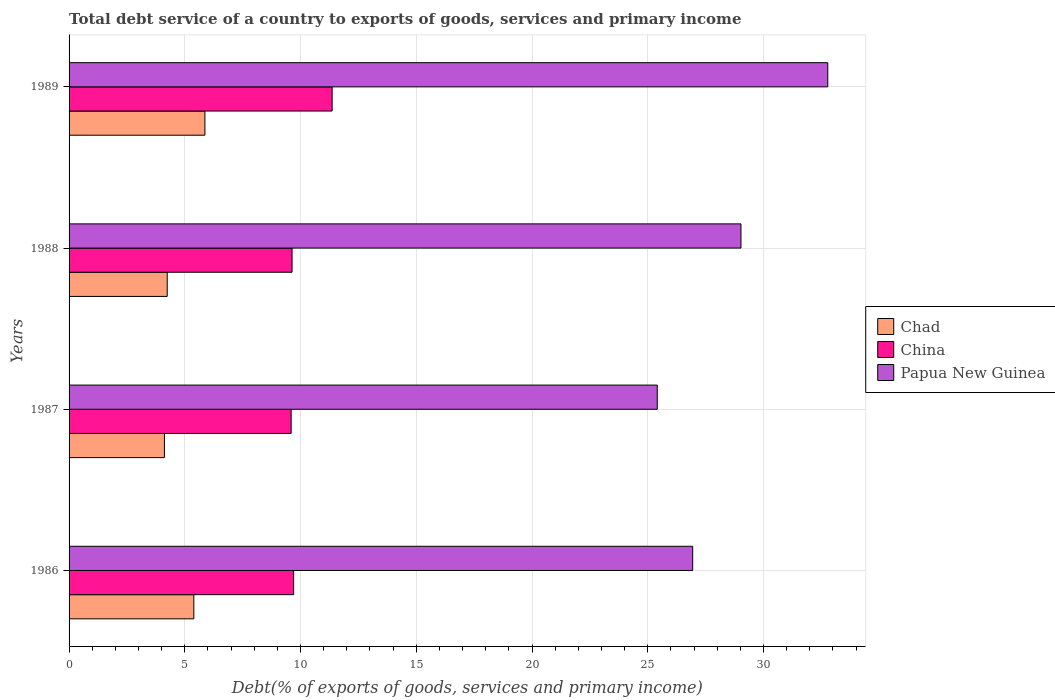Are the number of bars per tick equal to the number of legend labels?
Make the answer very short. Yes. How many bars are there on the 2nd tick from the bottom?
Provide a succinct answer. 3. In how many cases, is the number of bars for a given year not equal to the number of legend labels?
Offer a terse response. 0. What is the total debt service in Chad in 1986?
Offer a very short reply. 5.39. Across all years, what is the maximum total debt service in China?
Your answer should be very brief. 11.36. Across all years, what is the minimum total debt service in Chad?
Provide a succinct answer. 4.12. In which year was the total debt service in China maximum?
Provide a succinct answer. 1989. What is the total total debt service in Chad in the graph?
Offer a terse response. 19.62. What is the difference between the total debt service in Chad in 1987 and that in 1988?
Give a very brief answer. -0.12. What is the difference between the total debt service in China in 1987 and the total debt service in Chad in 1986?
Your answer should be very brief. 4.2. What is the average total debt service in Papua New Guinea per year?
Offer a very short reply. 28.54. In the year 1989, what is the difference between the total debt service in China and total debt service in Papua New Guinea?
Ensure brevity in your answer.  -21.41. What is the ratio of the total debt service in Chad in 1986 to that in 1989?
Offer a terse response. 0.92. Is the total debt service in China in 1987 less than that in 1988?
Give a very brief answer. Yes. What is the difference between the highest and the second highest total debt service in Chad?
Your answer should be compact. 0.48. What is the difference between the highest and the lowest total debt service in Chad?
Provide a short and direct response. 1.75. In how many years, is the total debt service in Papua New Guinea greater than the average total debt service in Papua New Guinea taken over all years?
Your response must be concise. 2. Is the sum of the total debt service in Chad in 1986 and 1987 greater than the maximum total debt service in Papua New Guinea across all years?
Provide a short and direct response. No. What does the 1st bar from the top in 1988 represents?
Keep it short and to the point. Papua New Guinea. How many bars are there?
Offer a very short reply. 12. Are the values on the major ticks of X-axis written in scientific E-notation?
Give a very brief answer. No. Where does the legend appear in the graph?
Provide a succinct answer. Center right. How are the legend labels stacked?
Offer a terse response. Vertical. What is the title of the graph?
Offer a terse response. Total debt service of a country to exports of goods, services and primary income. Does "San Marino" appear as one of the legend labels in the graph?
Provide a short and direct response. No. What is the label or title of the X-axis?
Ensure brevity in your answer.  Debt(% of exports of goods, services and primary income). What is the label or title of the Y-axis?
Your answer should be compact. Years. What is the Debt(% of exports of goods, services and primary income) of Chad in 1986?
Keep it short and to the point. 5.39. What is the Debt(% of exports of goods, services and primary income) in China in 1986?
Your answer should be very brief. 9.7. What is the Debt(% of exports of goods, services and primary income) of Papua New Guinea in 1986?
Provide a succinct answer. 26.94. What is the Debt(% of exports of goods, services and primary income) in Chad in 1987?
Your response must be concise. 4.12. What is the Debt(% of exports of goods, services and primary income) of China in 1987?
Ensure brevity in your answer.  9.59. What is the Debt(% of exports of goods, services and primary income) in Papua New Guinea in 1987?
Provide a short and direct response. 25.41. What is the Debt(% of exports of goods, services and primary income) of Chad in 1988?
Give a very brief answer. 4.24. What is the Debt(% of exports of goods, services and primary income) of China in 1988?
Keep it short and to the point. 9.63. What is the Debt(% of exports of goods, services and primary income) of Papua New Guinea in 1988?
Offer a terse response. 29.03. What is the Debt(% of exports of goods, services and primary income) in Chad in 1989?
Your answer should be compact. 5.87. What is the Debt(% of exports of goods, services and primary income) of China in 1989?
Ensure brevity in your answer.  11.36. What is the Debt(% of exports of goods, services and primary income) in Papua New Guinea in 1989?
Provide a succinct answer. 32.78. Across all years, what is the maximum Debt(% of exports of goods, services and primary income) in Chad?
Ensure brevity in your answer.  5.87. Across all years, what is the maximum Debt(% of exports of goods, services and primary income) in China?
Give a very brief answer. 11.36. Across all years, what is the maximum Debt(% of exports of goods, services and primary income) of Papua New Guinea?
Provide a short and direct response. 32.78. Across all years, what is the minimum Debt(% of exports of goods, services and primary income) of Chad?
Provide a succinct answer. 4.12. Across all years, what is the minimum Debt(% of exports of goods, services and primary income) of China?
Your response must be concise. 9.59. Across all years, what is the minimum Debt(% of exports of goods, services and primary income) in Papua New Guinea?
Your answer should be very brief. 25.41. What is the total Debt(% of exports of goods, services and primary income) of Chad in the graph?
Give a very brief answer. 19.62. What is the total Debt(% of exports of goods, services and primary income) in China in the graph?
Your answer should be very brief. 40.29. What is the total Debt(% of exports of goods, services and primary income) of Papua New Guinea in the graph?
Provide a short and direct response. 114.16. What is the difference between the Debt(% of exports of goods, services and primary income) of Chad in 1986 and that in 1987?
Give a very brief answer. 1.27. What is the difference between the Debt(% of exports of goods, services and primary income) of China in 1986 and that in 1987?
Keep it short and to the point. 0.11. What is the difference between the Debt(% of exports of goods, services and primary income) in Papua New Guinea in 1986 and that in 1987?
Give a very brief answer. 1.53. What is the difference between the Debt(% of exports of goods, services and primary income) of Chad in 1986 and that in 1988?
Make the answer very short. 1.15. What is the difference between the Debt(% of exports of goods, services and primary income) in China in 1986 and that in 1988?
Provide a succinct answer. 0.07. What is the difference between the Debt(% of exports of goods, services and primary income) of Papua New Guinea in 1986 and that in 1988?
Keep it short and to the point. -2.09. What is the difference between the Debt(% of exports of goods, services and primary income) in Chad in 1986 and that in 1989?
Give a very brief answer. -0.48. What is the difference between the Debt(% of exports of goods, services and primary income) in China in 1986 and that in 1989?
Your answer should be very brief. -1.66. What is the difference between the Debt(% of exports of goods, services and primary income) of Papua New Guinea in 1986 and that in 1989?
Provide a succinct answer. -5.84. What is the difference between the Debt(% of exports of goods, services and primary income) of Chad in 1987 and that in 1988?
Give a very brief answer. -0.12. What is the difference between the Debt(% of exports of goods, services and primary income) in China in 1987 and that in 1988?
Keep it short and to the point. -0.04. What is the difference between the Debt(% of exports of goods, services and primary income) of Papua New Guinea in 1987 and that in 1988?
Your answer should be very brief. -3.62. What is the difference between the Debt(% of exports of goods, services and primary income) in Chad in 1987 and that in 1989?
Your answer should be compact. -1.75. What is the difference between the Debt(% of exports of goods, services and primary income) in China in 1987 and that in 1989?
Give a very brief answer. -1.77. What is the difference between the Debt(% of exports of goods, services and primary income) of Papua New Guinea in 1987 and that in 1989?
Make the answer very short. -7.37. What is the difference between the Debt(% of exports of goods, services and primary income) in Chad in 1988 and that in 1989?
Offer a very short reply. -1.63. What is the difference between the Debt(% of exports of goods, services and primary income) in China in 1988 and that in 1989?
Make the answer very short. -1.73. What is the difference between the Debt(% of exports of goods, services and primary income) of Papua New Guinea in 1988 and that in 1989?
Provide a short and direct response. -3.75. What is the difference between the Debt(% of exports of goods, services and primary income) of Chad in 1986 and the Debt(% of exports of goods, services and primary income) of China in 1987?
Your answer should be very brief. -4.2. What is the difference between the Debt(% of exports of goods, services and primary income) of Chad in 1986 and the Debt(% of exports of goods, services and primary income) of Papua New Guinea in 1987?
Ensure brevity in your answer.  -20.02. What is the difference between the Debt(% of exports of goods, services and primary income) in China in 1986 and the Debt(% of exports of goods, services and primary income) in Papua New Guinea in 1987?
Give a very brief answer. -15.71. What is the difference between the Debt(% of exports of goods, services and primary income) in Chad in 1986 and the Debt(% of exports of goods, services and primary income) in China in 1988?
Keep it short and to the point. -4.24. What is the difference between the Debt(% of exports of goods, services and primary income) in Chad in 1986 and the Debt(% of exports of goods, services and primary income) in Papua New Guinea in 1988?
Your answer should be very brief. -23.64. What is the difference between the Debt(% of exports of goods, services and primary income) of China in 1986 and the Debt(% of exports of goods, services and primary income) of Papua New Guinea in 1988?
Your response must be concise. -19.33. What is the difference between the Debt(% of exports of goods, services and primary income) in Chad in 1986 and the Debt(% of exports of goods, services and primary income) in China in 1989?
Your answer should be compact. -5.98. What is the difference between the Debt(% of exports of goods, services and primary income) of Chad in 1986 and the Debt(% of exports of goods, services and primary income) of Papua New Guinea in 1989?
Give a very brief answer. -27.39. What is the difference between the Debt(% of exports of goods, services and primary income) of China in 1986 and the Debt(% of exports of goods, services and primary income) of Papua New Guinea in 1989?
Offer a very short reply. -23.08. What is the difference between the Debt(% of exports of goods, services and primary income) of Chad in 1987 and the Debt(% of exports of goods, services and primary income) of China in 1988?
Ensure brevity in your answer.  -5.51. What is the difference between the Debt(% of exports of goods, services and primary income) in Chad in 1987 and the Debt(% of exports of goods, services and primary income) in Papua New Guinea in 1988?
Your answer should be very brief. -24.91. What is the difference between the Debt(% of exports of goods, services and primary income) of China in 1987 and the Debt(% of exports of goods, services and primary income) of Papua New Guinea in 1988?
Ensure brevity in your answer.  -19.43. What is the difference between the Debt(% of exports of goods, services and primary income) in Chad in 1987 and the Debt(% of exports of goods, services and primary income) in China in 1989?
Provide a succinct answer. -7.25. What is the difference between the Debt(% of exports of goods, services and primary income) in Chad in 1987 and the Debt(% of exports of goods, services and primary income) in Papua New Guinea in 1989?
Make the answer very short. -28.66. What is the difference between the Debt(% of exports of goods, services and primary income) of China in 1987 and the Debt(% of exports of goods, services and primary income) of Papua New Guinea in 1989?
Provide a succinct answer. -23.18. What is the difference between the Debt(% of exports of goods, services and primary income) in Chad in 1988 and the Debt(% of exports of goods, services and primary income) in China in 1989?
Your response must be concise. -7.12. What is the difference between the Debt(% of exports of goods, services and primary income) in Chad in 1988 and the Debt(% of exports of goods, services and primary income) in Papua New Guinea in 1989?
Your response must be concise. -28.54. What is the difference between the Debt(% of exports of goods, services and primary income) in China in 1988 and the Debt(% of exports of goods, services and primary income) in Papua New Guinea in 1989?
Ensure brevity in your answer.  -23.14. What is the average Debt(% of exports of goods, services and primary income) in Chad per year?
Provide a succinct answer. 4.9. What is the average Debt(% of exports of goods, services and primary income) of China per year?
Offer a terse response. 10.07. What is the average Debt(% of exports of goods, services and primary income) of Papua New Guinea per year?
Ensure brevity in your answer.  28.54. In the year 1986, what is the difference between the Debt(% of exports of goods, services and primary income) in Chad and Debt(% of exports of goods, services and primary income) in China?
Keep it short and to the point. -4.31. In the year 1986, what is the difference between the Debt(% of exports of goods, services and primary income) in Chad and Debt(% of exports of goods, services and primary income) in Papua New Guinea?
Your answer should be very brief. -21.55. In the year 1986, what is the difference between the Debt(% of exports of goods, services and primary income) of China and Debt(% of exports of goods, services and primary income) of Papua New Guinea?
Offer a terse response. -17.24. In the year 1987, what is the difference between the Debt(% of exports of goods, services and primary income) of Chad and Debt(% of exports of goods, services and primary income) of China?
Keep it short and to the point. -5.47. In the year 1987, what is the difference between the Debt(% of exports of goods, services and primary income) in Chad and Debt(% of exports of goods, services and primary income) in Papua New Guinea?
Your response must be concise. -21.29. In the year 1987, what is the difference between the Debt(% of exports of goods, services and primary income) in China and Debt(% of exports of goods, services and primary income) in Papua New Guinea?
Offer a very short reply. -15.82. In the year 1988, what is the difference between the Debt(% of exports of goods, services and primary income) in Chad and Debt(% of exports of goods, services and primary income) in China?
Keep it short and to the point. -5.39. In the year 1988, what is the difference between the Debt(% of exports of goods, services and primary income) of Chad and Debt(% of exports of goods, services and primary income) of Papua New Guinea?
Offer a terse response. -24.79. In the year 1988, what is the difference between the Debt(% of exports of goods, services and primary income) of China and Debt(% of exports of goods, services and primary income) of Papua New Guinea?
Make the answer very short. -19.39. In the year 1989, what is the difference between the Debt(% of exports of goods, services and primary income) of Chad and Debt(% of exports of goods, services and primary income) of China?
Keep it short and to the point. -5.5. In the year 1989, what is the difference between the Debt(% of exports of goods, services and primary income) of Chad and Debt(% of exports of goods, services and primary income) of Papua New Guinea?
Offer a terse response. -26.91. In the year 1989, what is the difference between the Debt(% of exports of goods, services and primary income) in China and Debt(% of exports of goods, services and primary income) in Papua New Guinea?
Your response must be concise. -21.41. What is the ratio of the Debt(% of exports of goods, services and primary income) in Chad in 1986 to that in 1987?
Your answer should be compact. 1.31. What is the ratio of the Debt(% of exports of goods, services and primary income) in China in 1986 to that in 1987?
Provide a succinct answer. 1.01. What is the ratio of the Debt(% of exports of goods, services and primary income) of Papua New Guinea in 1986 to that in 1987?
Your response must be concise. 1.06. What is the ratio of the Debt(% of exports of goods, services and primary income) in Chad in 1986 to that in 1988?
Your answer should be compact. 1.27. What is the ratio of the Debt(% of exports of goods, services and primary income) of Papua New Guinea in 1986 to that in 1988?
Offer a terse response. 0.93. What is the ratio of the Debt(% of exports of goods, services and primary income) of Chad in 1986 to that in 1989?
Your answer should be compact. 0.92. What is the ratio of the Debt(% of exports of goods, services and primary income) in China in 1986 to that in 1989?
Ensure brevity in your answer.  0.85. What is the ratio of the Debt(% of exports of goods, services and primary income) of Papua New Guinea in 1986 to that in 1989?
Provide a short and direct response. 0.82. What is the ratio of the Debt(% of exports of goods, services and primary income) of Chad in 1987 to that in 1988?
Offer a terse response. 0.97. What is the ratio of the Debt(% of exports of goods, services and primary income) in China in 1987 to that in 1988?
Your response must be concise. 1. What is the ratio of the Debt(% of exports of goods, services and primary income) of Papua New Guinea in 1987 to that in 1988?
Provide a short and direct response. 0.88. What is the ratio of the Debt(% of exports of goods, services and primary income) of Chad in 1987 to that in 1989?
Give a very brief answer. 0.7. What is the ratio of the Debt(% of exports of goods, services and primary income) in China in 1987 to that in 1989?
Make the answer very short. 0.84. What is the ratio of the Debt(% of exports of goods, services and primary income) of Papua New Guinea in 1987 to that in 1989?
Provide a short and direct response. 0.78. What is the ratio of the Debt(% of exports of goods, services and primary income) of Chad in 1988 to that in 1989?
Make the answer very short. 0.72. What is the ratio of the Debt(% of exports of goods, services and primary income) in China in 1988 to that in 1989?
Provide a short and direct response. 0.85. What is the ratio of the Debt(% of exports of goods, services and primary income) in Papua New Guinea in 1988 to that in 1989?
Ensure brevity in your answer.  0.89. What is the difference between the highest and the second highest Debt(% of exports of goods, services and primary income) of Chad?
Give a very brief answer. 0.48. What is the difference between the highest and the second highest Debt(% of exports of goods, services and primary income) of China?
Ensure brevity in your answer.  1.66. What is the difference between the highest and the second highest Debt(% of exports of goods, services and primary income) of Papua New Guinea?
Give a very brief answer. 3.75. What is the difference between the highest and the lowest Debt(% of exports of goods, services and primary income) in Chad?
Make the answer very short. 1.75. What is the difference between the highest and the lowest Debt(% of exports of goods, services and primary income) in China?
Make the answer very short. 1.77. What is the difference between the highest and the lowest Debt(% of exports of goods, services and primary income) in Papua New Guinea?
Offer a terse response. 7.37. 